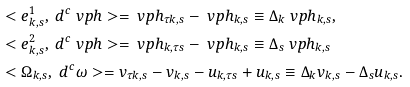<formula> <loc_0><loc_0><loc_500><loc_500>& < e ^ { 1 } _ { k , s } , \ d ^ { c } \ v p h > = \ v p h _ { \tau k , s } - \ v p h _ { k , s } \equiv \Delta _ { k } \ v p h _ { k , s } , \\ & < e ^ { 2 } _ { k , s } , \ d ^ { c } \ v p h > = \ v p h _ { k , \tau s } - \ v p h _ { k , s } \equiv \Delta _ { s } \ v p h _ { k , s } \\ & < \Omega _ { k , s } , \ d ^ { c } \omega > = v _ { \tau k , s } - v _ { k , s } - u _ { k , \tau s } + u _ { k , s } \equiv \Delta _ { k } v _ { k , s } - \Delta _ { s } u _ { k , s } .</formula> 